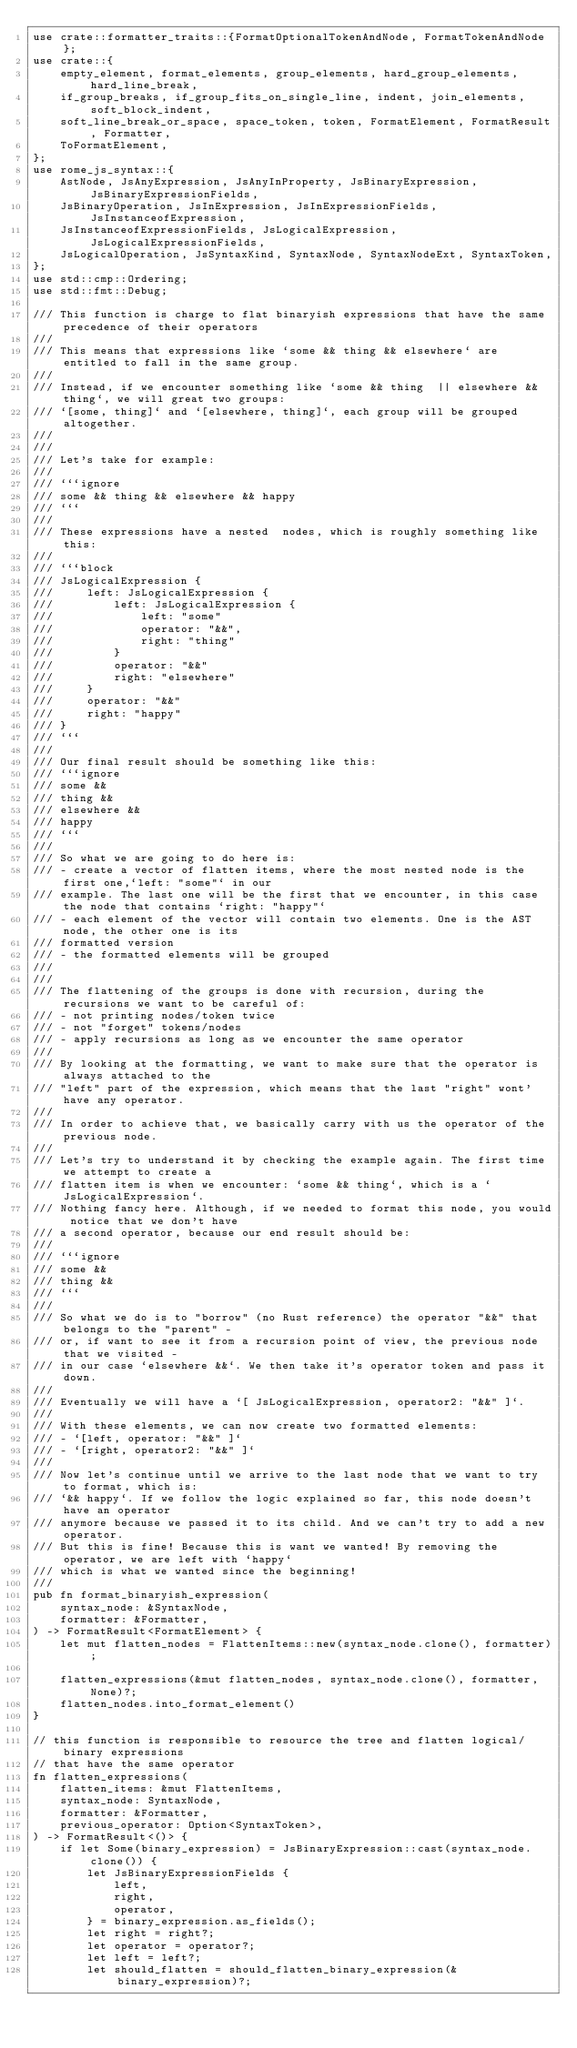Convert code to text. <code><loc_0><loc_0><loc_500><loc_500><_Rust_>use crate::formatter_traits::{FormatOptionalTokenAndNode, FormatTokenAndNode};
use crate::{
    empty_element, format_elements, group_elements, hard_group_elements, hard_line_break,
    if_group_breaks, if_group_fits_on_single_line, indent, join_elements, soft_block_indent,
    soft_line_break_or_space, space_token, token, FormatElement, FormatResult, Formatter,
    ToFormatElement,
};
use rome_js_syntax::{
    AstNode, JsAnyExpression, JsAnyInProperty, JsBinaryExpression, JsBinaryExpressionFields,
    JsBinaryOperation, JsInExpression, JsInExpressionFields, JsInstanceofExpression,
    JsInstanceofExpressionFields, JsLogicalExpression, JsLogicalExpressionFields,
    JsLogicalOperation, JsSyntaxKind, SyntaxNode, SyntaxNodeExt, SyntaxToken,
};
use std::cmp::Ordering;
use std::fmt::Debug;

/// This function is charge to flat binaryish expressions that have the same precedence of their operators
///
/// This means that expressions like `some && thing && elsewhere` are entitled to fall in the same group.
///
/// Instead, if we encounter something like `some && thing  || elsewhere && thing`, we will great two groups:
/// `[some, thing]` and `[elsewhere, thing]`, each group will be grouped altogether.
///
///
/// Let's take for example:
///
/// ```ignore
/// some && thing && elsewhere && happy
/// ```
///
/// These expressions have a nested  nodes, which is roughly something like this:
///
/// ```block
/// JsLogicalExpression {
///     left: JsLogicalExpression {
///         left: JsLogicalExpression {
///             left: "some"
///             operator: "&&",
///             right: "thing"
///         }
///         operator: "&&"
///         right: "elsewhere"
///     }
///     operator: "&&"
///     right: "happy"
/// }
/// ```
///
/// Our final result should be something like this:
/// ```ignore
/// some &&
/// thing &&
/// elsewhere &&
/// happy
/// ```
///
/// So what we are going to do here is:
/// - create a vector of flatten items, where the most nested node is the first one,`left: "some"` in our
/// example. The last one will be the first that we encounter, in this case the node that contains `right: "happy"`
/// - each element of the vector will contain two elements. One is the AST node, the other one is its
/// formatted version
/// - the formatted elements will be grouped
///
///
/// The flattening of the groups is done with recursion, during the recursions we want to be careful of:
/// - not printing nodes/token twice
/// - not "forget" tokens/nodes
/// - apply recursions as long as we encounter the same operator
///
/// By looking at the formatting, we want to make sure that the operator is always attached to the
/// "left" part of the expression, which means that the last "right" wont' have any operator.
///
/// In order to achieve that, we basically carry with us the operator of the previous node.
///
/// Let's try to understand it by checking the example again. The first time we attempt to create a
/// flatten item is when we encounter: `some && thing`, which is a `JsLogicalExpression`.
/// Nothing fancy here. Although, if we needed to format this node, you would notice that we don't have
/// a second operator, because our end result should be:
///
/// ```ignore
/// some &&
/// thing &&
/// ```
///
/// So what we do is to "borrow" (no Rust reference) the operator "&&" that belongs to the "parent" -
/// or, if want to see it from a recursion point of view, the previous node that we visited -
/// in our case `elsewhere &&`. We then take it's operator token and pass it down.
///
/// Eventually we will have a `[ JsLogicalExpression, operator2: "&&" ]`.
///
/// With these elements, we can now create two formatted elements:
/// - `[left, operator: "&&" ]`
/// - `[right, operator2: "&&" ]`
///
/// Now let's continue until we arrive to the last node that we want to try to format, which is:
/// `&& happy`. If we follow the logic explained so far, this node doesn't have an operator
/// anymore because we passed it to its child. And we can't try to add a new operator.
/// But this is fine! Because this is want we wanted! By removing the operator, we are left with `happy`
/// which is what we wanted since the beginning!
///
pub fn format_binaryish_expression(
    syntax_node: &SyntaxNode,
    formatter: &Formatter,
) -> FormatResult<FormatElement> {
    let mut flatten_nodes = FlattenItems::new(syntax_node.clone(), formatter);

    flatten_expressions(&mut flatten_nodes, syntax_node.clone(), formatter, None)?;
    flatten_nodes.into_format_element()
}

// this function is responsible to resource the tree and flatten logical/binary expressions
// that have the same operator
fn flatten_expressions(
    flatten_items: &mut FlattenItems,
    syntax_node: SyntaxNode,
    formatter: &Formatter,
    previous_operator: Option<SyntaxToken>,
) -> FormatResult<()> {
    if let Some(binary_expression) = JsBinaryExpression::cast(syntax_node.clone()) {
        let JsBinaryExpressionFields {
            left,
            right,
            operator,
        } = binary_expression.as_fields();
        let right = right?;
        let operator = operator?;
        let left = left?;
        let should_flatten = should_flatten_binary_expression(&binary_expression)?;
</code> 